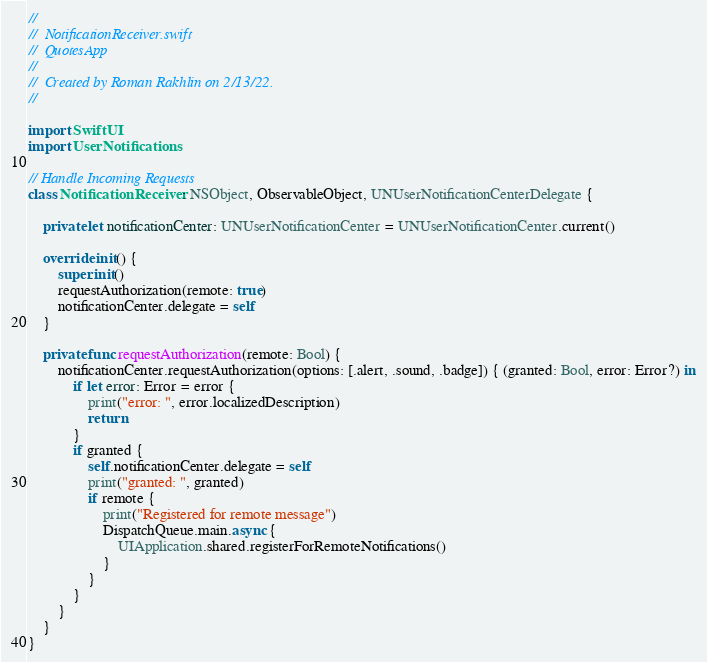Convert code to text. <code><loc_0><loc_0><loc_500><loc_500><_Swift_>//
//  NotificationReceiver.swift
//  QuotesApp
//
//  Created by Roman Rakhlin on 2/13/22.
//

import SwiftUI
import UserNotifications

// Handle Incoming Requests
class NotificationReceiver: NSObject, ObservableObject, UNUserNotificationCenterDelegate {
    
    private let notificationCenter: UNUserNotificationCenter = UNUserNotificationCenter.current()
    
    override init() {
        super.init()
        requestAuthorization(remote: true)
        notificationCenter.delegate = self
    }
    
    private func requestAuthorization(remote: Bool) {
        notificationCenter.requestAuthorization(options: [.alert, .sound, .badge]) { (granted: Bool, error: Error?) in
            if let error: Error = error {
                print("error: ", error.localizedDescription)
                return
            }
            if granted {
                self.notificationCenter.delegate = self
                print("granted: ", granted)
                if remote {
                    print("Registered for remote message")
                    DispatchQueue.main.async {
                        UIApplication.shared.registerForRemoteNotifications()
                    }
                }
            }
        }
    }
}
</code> 